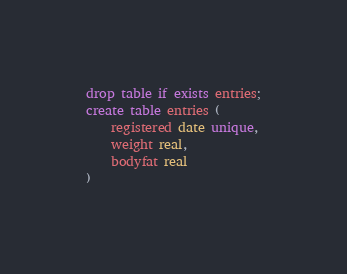<code> <loc_0><loc_0><loc_500><loc_500><_SQL_>drop table if exists entries;
create table entries (
	registered date unique,
	weight real,
	bodyfat real
)
</code> 